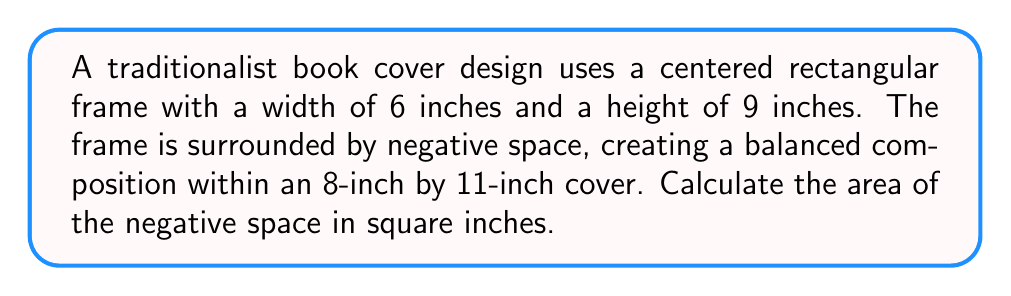Teach me how to tackle this problem. To solve this problem, we'll follow these steps:

1. Calculate the total area of the book cover:
   $$A_{total} = 8 \text{ in} \times 11 \text{ in} = 88 \text{ sq in}$$

2. Calculate the area of the centered rectangular frame:
   $$A_{frame} = 6 \text{ in} \times 9 \text{ in} = 54 \text{ sq in}$$

3. Calculate the area of the negative space by subtracting the frame area from the total area:
   $$A_{negative} = A_{total} - A_{frame}$$
   $$A_{negative} = 88 \text{ sq in} - 54 \text{ sq in} = 34 \text{ sq in}$$

Therefore, the area of the negative space in the balanced traditionalist cover composition is 34 square inches.
Answer: 34 sq in 